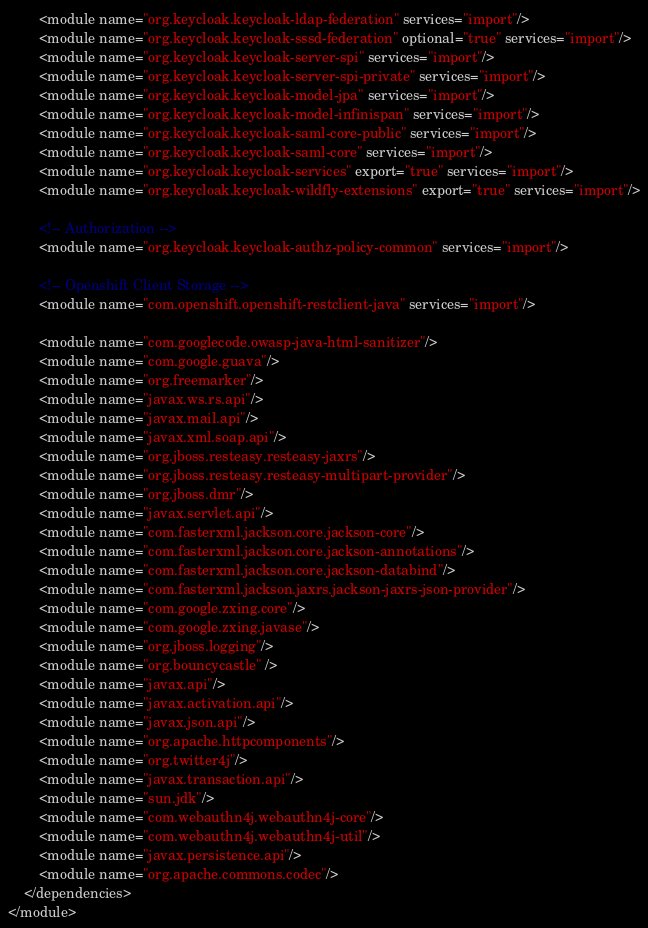Convert code to text. <code><loc_0><loc_0><loc_500><loc_500><_XML_>        <module name="org.keycloak.keycloak-ldap-federation" services="import"/>
        <module name="org.keycloak.keycloak-sssd-federation" optional="true" services="import"/>
        <module name="org.keycloak.keycloak-server-spi" services="import"/>
        <module name="org.keycloak.keycloak-server-spi-private" services="import"/>
        <module name="org.keycloak.keycloak-model-jpa" services="import"/>
        <module name="org.keycloak.keycloak-model-infinispan" services="import"/>
        <module name="org.keycloak.keycloak-saml-core-public" services="import"/>
        <module name="org.keycloak.keycloak-saml-core" services="import"/>
        <module name="org.keycloak.keycloak-services" export="true" services="import"/>
        <module name="org.keycloak.keycloak-wildfly-extensions" export="true" services="import"/>

        <!-- Authorization -->
        <module name="org.keycloak.keycloak-authz-policy-common" services="import"/>

        <!-- Openshift Client Storage -->
        <module name="com.openshift.openshift-restclient-java" services="import"/>

        <module name="com.googlecode.owasp-java-html-sanitizer"/>
        <module name="com.google.guava"/>
        <module name="org.freemarker"/>
        <module name="javax.ws.rs.api"/>
        <module name="javax.mail.api"/>
        <module name="javax.xml.soap.api"/>
        <module name="org.jboss.resteasy.resteasy-jaxrs"/>
        <module name="org.jboss.resteasy.resteasy-multipart-provider"/>
        <module name="org.jboss.dmr"/>
        <module name="javax.servlet.api"/>
        <module name="com.fasterxml.jackson.core.jackson-core"/>
        <module name="com.fasterxml.jackson.core.jackson-annotations"/>
        <module name="com.fasterxml.jackson.core.jackson-databind"/>
        <module name="com.fasterxml.jackson.jaxrs.jackson-jaxrs-json-provider"/>
        <module name="com.google.zxing.core"/>
        <module name="com.google.zxing.javase"/>
        <module name="org.jboss.logging"/>
        <module name="org.bouncycastle" />
        <module name="javax.api"/>
        <module name="javax.activation.api"/>
        <module name="javax.json.api"/>
        <module name="org.apache.httpcomponents"/>
        <module name="org.twitter4j"/>
        <module name="javax.transaction.api"/>
        <module name="sun.jdk"/>
        <module name="com.webauthn4j.webauthn4j-core"/>
        <module name="com.webauthn4j.webauthn4j-util"/>
        <module name="javax.persistence.api"/>
        <module name="org.apache.commons.codec"/>
    </dependencies>
</module>
</code> 